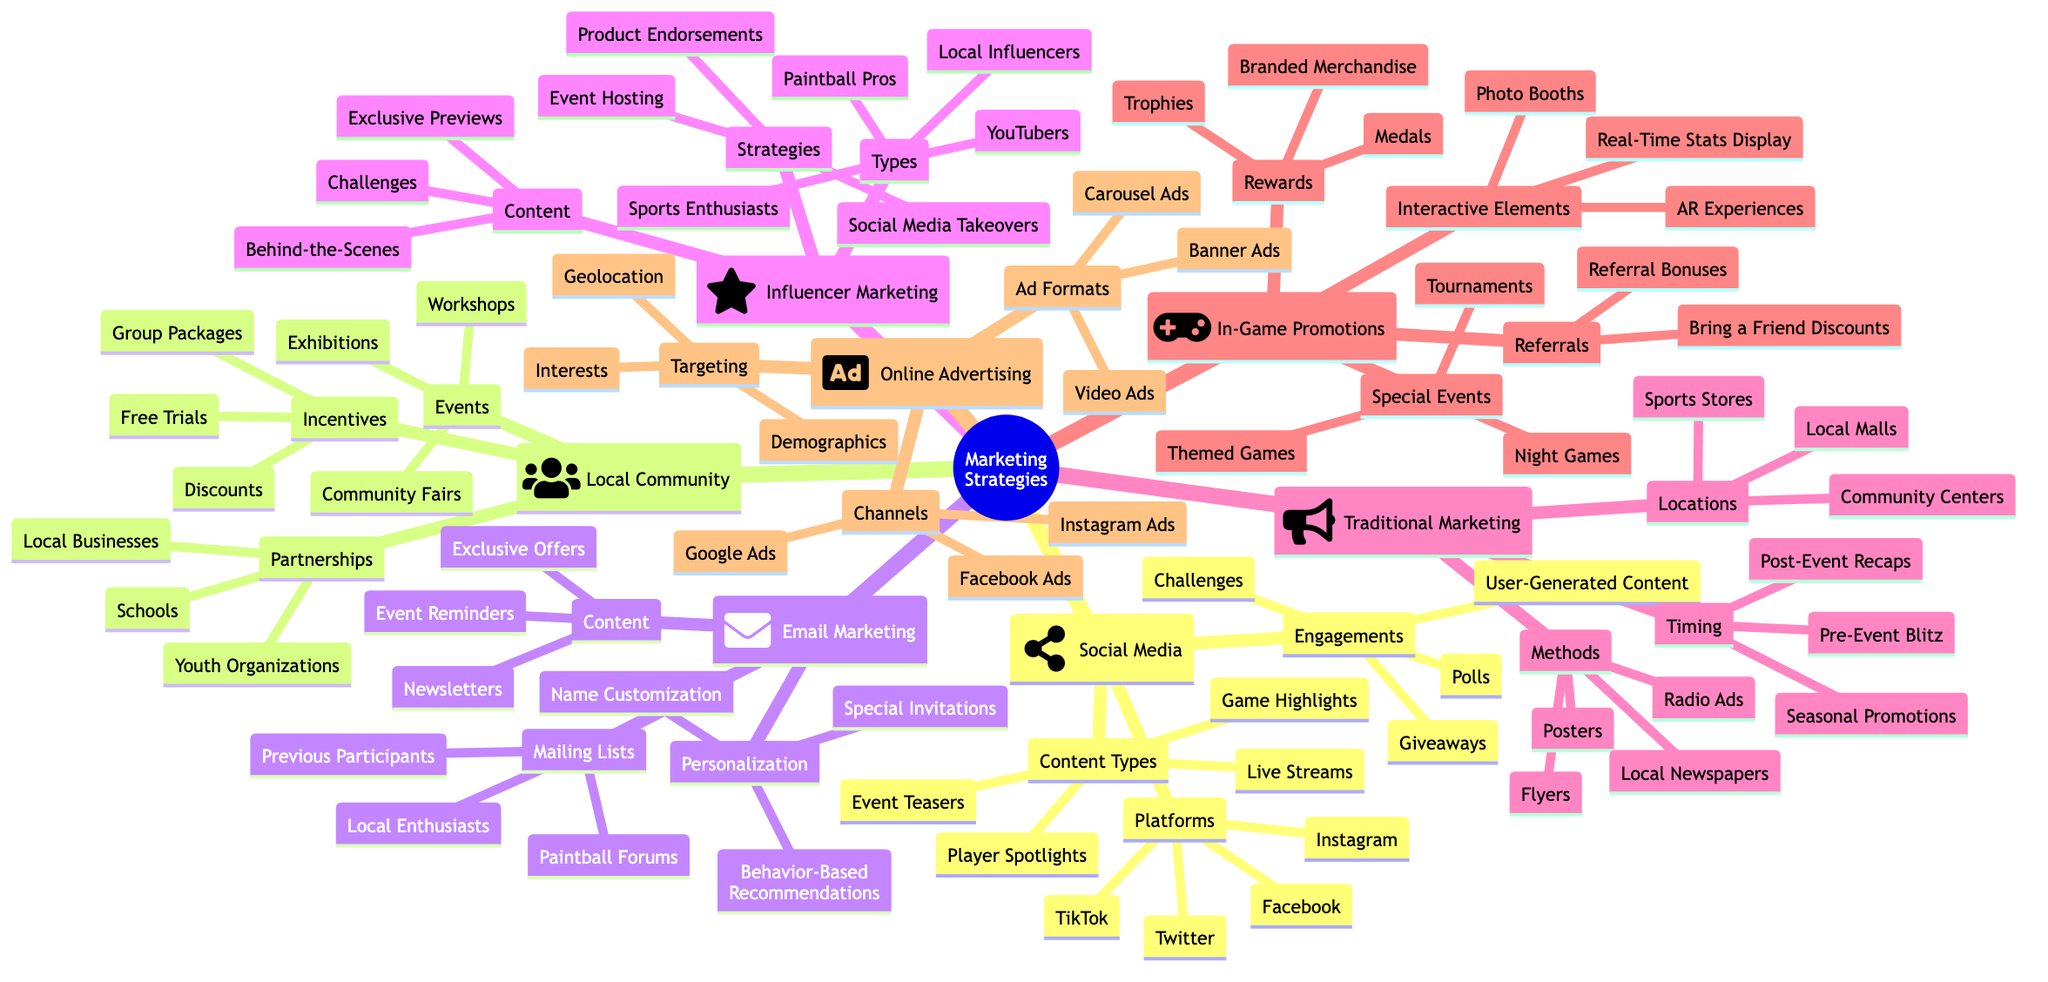What's the number of platforms listed under Social Media? There are four platforms listed: Facebook, Instagram, Twitter, and TikTok. By counting these items, we find the total number to be four.
Answer: 4 Which types of partnerships are mentioned in Local Community Engagement? The partnerships listed are Local Businesses, Schools, and Youth Organizations. By identifying the partnerships node and reading its sub-items, I retrieved these three types.
Answer: Local Businesses, Schools, Youth Organizations How many engagement types are included in Social Media Campaigns? The engagement types listed are Polls, Challenges, Giveaways, and User-Generated Content. Counting these four items gives a total of four engagement types.
Answer: 4 What type of content is included in Email Marketing? The content types in Email Marketing are Newsletters, Exclusive Offers, and Event Reminders. By identifying the content node, I counted three specific content types.
Answer: Newsletters, Exclusive Offers, Event Reminders Which rewards are offered during In-Game Promotions? The rewards listed are Trophies, Medals, and Branded Merchandise. By examining the rewards section under In-Game Promotions, I noted these three rewards offered during events.
Answer: Trophies, Medals, Branded Merchandise What are the channels used in Online Advertising? The channels mentioned are Google Ads, Facebook Ads, and Instagram Ads. By checking the channels node, I confirmed these three specific channels used for advertising.
Answer: Google Ads, Facebook Ads, Instagram Ads Which strategies are listed under Influencer Marketing? The strategies identified are Product Endorsements, Event Hosting, and Social Media Takeovers. These were gathered from the strategies section under Influencer Marketing, giving a total of three strategies.
Answer: Product Endorsements, Event Hosting, Social Media Takeovers What type of interactive elements are included in In-Game Promotions? The interactive elements include Photo Booths, AR Experiences, and Real-Time Stats Display. These were found by referencing the interactive elements node and counting the three specific items listed.
Answer: Photo Booths, AR Experiences, Real-Time Stats Display How many methods fall under Traditional Marketing? There are four methods listed: Flyers, Posters, Local Newspapers, and Radio Ads. After examining the methods node in Traditional Marketing, I counted these four distinct methods.
Answer: 4 